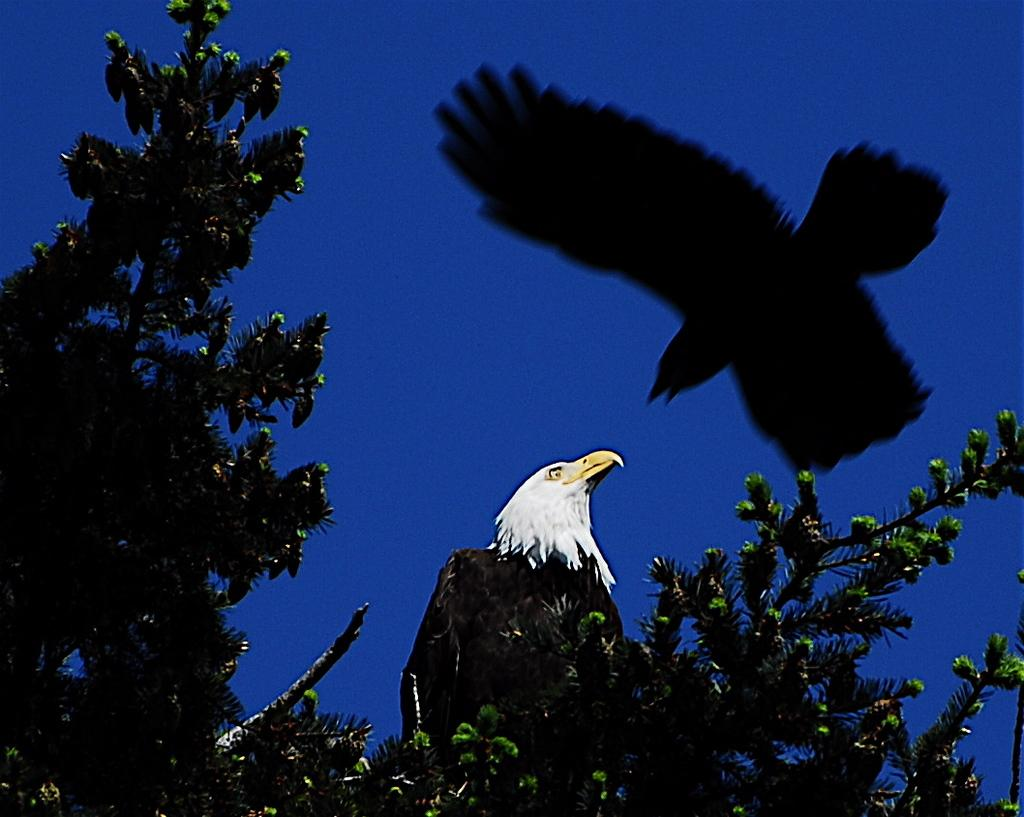What is the main object in the image? There is a branch of a tree with leaves in the image. Are there any animals present in the image? Yes, there is a bird in the image. What color is the background of the image? The background of the image is blue. Can you describe any additional features in the image? There is a shadow of a bird flying in the image. Who is the owner of the beef in the image? There is no beef present in the image, so it is not possible to determine an owner. 